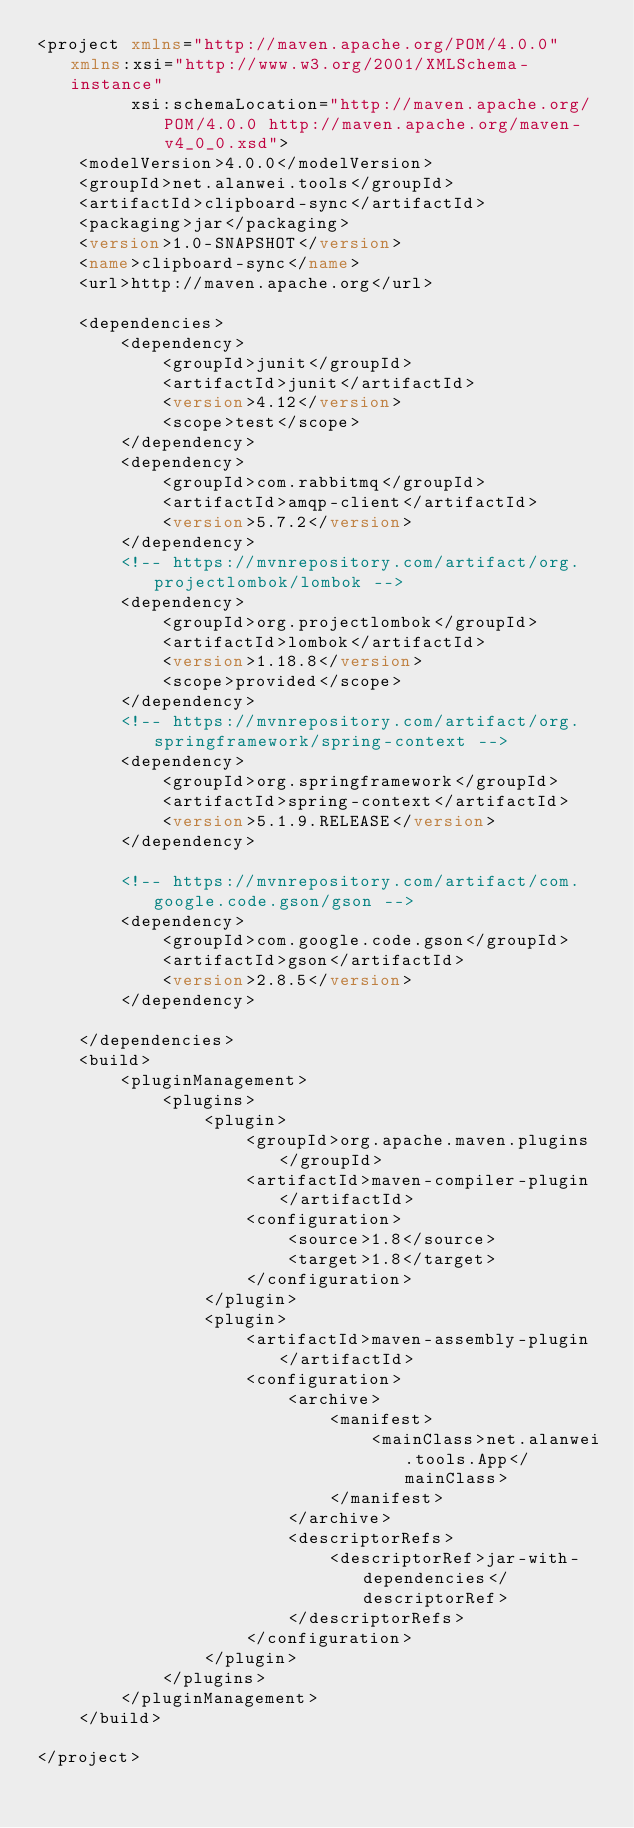Convert code to text. <code><loc_0><loc_0><loc_500><loc_500><_XML_><project xmlns="http://maven.apache.org/POM/4.0.0" xmlns:xsi="http://www.w3.org/2001/XMLSchema-instance"
         xsi:schemaLocation="http://maven.apache.org/POM/4.0.0 http://maven.apache.org/maven-v4_0_0.xsd">
    <modelVersion>4.0.0</modelVersion>
    <groupId>net.alanwei.tools</groupId>
    <artifactId>clipboard-sync</artifactId>
    <packaging>jar</packaging>
    <version>1.0-SNAPSHOT</version>
    <name>clipboard-sync</name>
    <url>http://maven.apache.org</url>

    <dependencies>
        <dependency>
            <groupId>junit</groupId>
            <artifactId>junit</artifactId>
            <version>4.12</version>
            <scope>test</scope>
        </dependency>
        <dependency>
            <groupId>com.rabbitmq</groupId>
            <artifactId>amqp-client</artifactId>
            <version>5.7.2</version>
        </dependency>
        <!-- https://mvnrepository.com/artifact/org.projectlombok/lombok -->
        <dependency>
            <groupId>org.projectlombok</groupId>
            <artifactId>lombok</artifactId>
            <version>1.18.8</version>
            <scope>provided</scope>
        </dependency>
        <!-- https://mvnrepository.com/artifact/org.springframework/spring-context -->
        <dependency>
            <groupId>org.springframework</groupId>
            <artifactId>spring-context</artifactId>
            <version>5.1.9.RELEASE</version>
        </dependency>

        <!-- https://mvnrepository.com/artifact/com.google.code.gson/gson -->
        <dependency>
            <groupId>com.google.code.gson</groupId>
            <artifactId>gson</artifactId>
            <version>2.8.5</version>
        </dependency>

    </dependencies>
    <build>
        <pluginManagement>
            <plugins>
                <plugin>
                    <groupId>org.apache.maven.plugins</groupId>
                    <artifactId>maven-compiler-plugin</artifactId>
                    <configuration>
                        <source>1.8</source>
                        <target>1.8</target>
                    </configuration>
                </plugin>
                <plugin>
                    <artifactId>maven-assembly-plugin</artifactId>
                    <configuration>
                        <archive>
                            <manifest>
                                <mainClass>net.alanwei.tools.App</mainClass>
                            </manifest>
                        </archive>
                        <descriptorRefs>
                            <descriptorRef>jar-with-dependencies</descriptorRef>
                        </descriptorRefs>
                    </configuration>
                </plugin>
            </plugins>
        </pluginManagement>
    </build>

</project>
</code> 